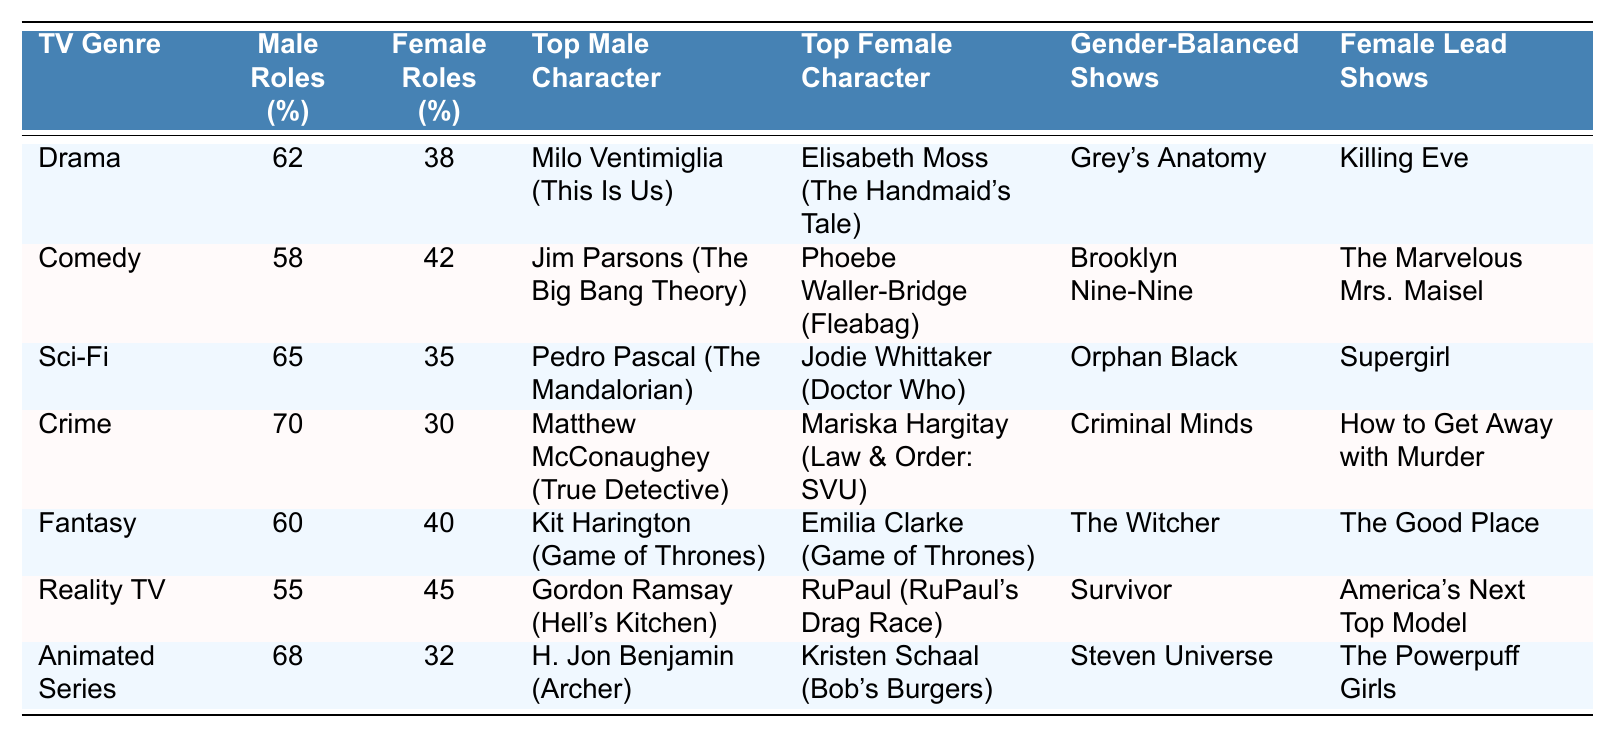What is the percentage of male speaking roles in the Crime genre? The table shows that the percentage of male speaking roles in the Crime genre is 70%.
Answer: 70% Which TV genre has the highest percentage of female speaking roles? By comparing the percentages of female speaking roles across all genres, Reality TV has the highest percentage at 45%.
Answer: 45% Is there a TV genre where female speaking roles are greater than male speaking roles? In the table, Reality TV shows 45% female roles and 55% male roles, so no genre has more female than male speaking roles.
Answer: No List the top female character in the Sci-Fi genre. The table indicates that the top female character in the Sci-Fi genre is Jodie Whittaker, featured in Doctor Who.
Answer: Jodie Whittaker What is the average percentage of male speaking roles across all genres? To calculate the average, sum the male percentages (62 + 58 + 65 + 70 + 60 + 55 + 68 = 408) and divide by the number of genres (7). The average is 408/7 ≈ 58.29%.
Answer: 58.29% Which genres have shows with a gender-balanced cast? The table lists Grey's Anatomy, Brooklyn Nine-Nine, Orphan Black, Criminal Minds, The Witcher, Survivor, and Steven Universe as shows with a gender-balanced cast.
Answer: 7 shows Are there more genres with shows featuring a female lead than those with a gender-balanced cast? The table outlines 7 shows with a gender-balanced cast and 7 shows with female leads, indicating they are equal in number.
Answer: No What is the difference in percentage of speaking roles between males and females in the Fantasy genre? The male speaking role percentage in the Fantasy genre is 60% and female is 40%, making the difference 60 - 40 = 20%.
Answer: 20% Which genre has the lowest percentage of female speaking roles? Analyzing the table, the Crime genre has the lowest percentage of female speaking roles at 30%.
Answer: Crime Identify the show with the female lead in the Reality TV genre. The table lists America's Next Top Model as the show with a female lead in the Reality TV genre.
Answer: America's Next Top Model What percentage of speaking roles do males have in genres where there are female leads? In the genres with female leads (Drama, Comedy, Sci-Fi, Crime, Fantasy, Reality TV, Animated Series), sum the male percentages and average them: (62 + 58 + 65 + 70 + 60 + 55 + 68 = 408)b; average percentage = 408/7 = 58.29%.
Answer: 58.29% 